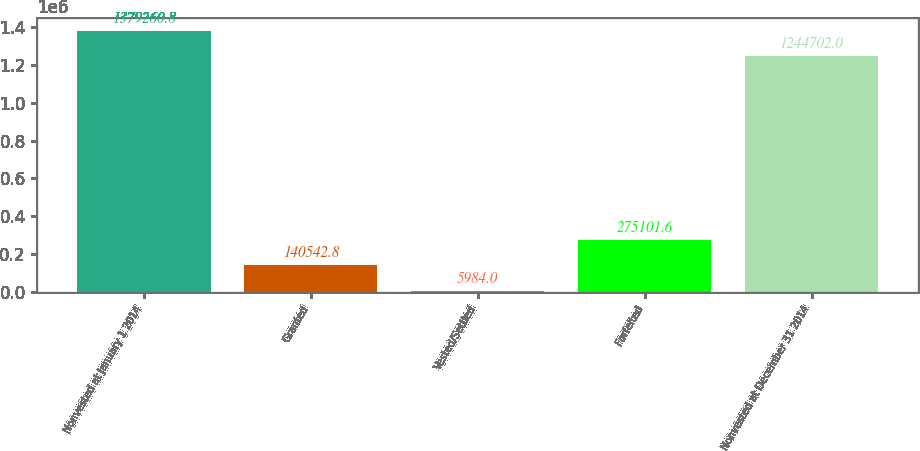Convert chart to OTSL. <chart><loc_0><loc_0><loc_500><loc_500><bar_chart><fcel>Nonvested at January 1 2014<fcel>Granted<fcel>Vested/Settled<fcel>Forfeited<fcel>Nonvested at December 31 2014<nl><fcel>1.37926e+06<fcel>140543<fcel>5984<fcel>275102<fcel>1.2447e+06<nl></chart> 